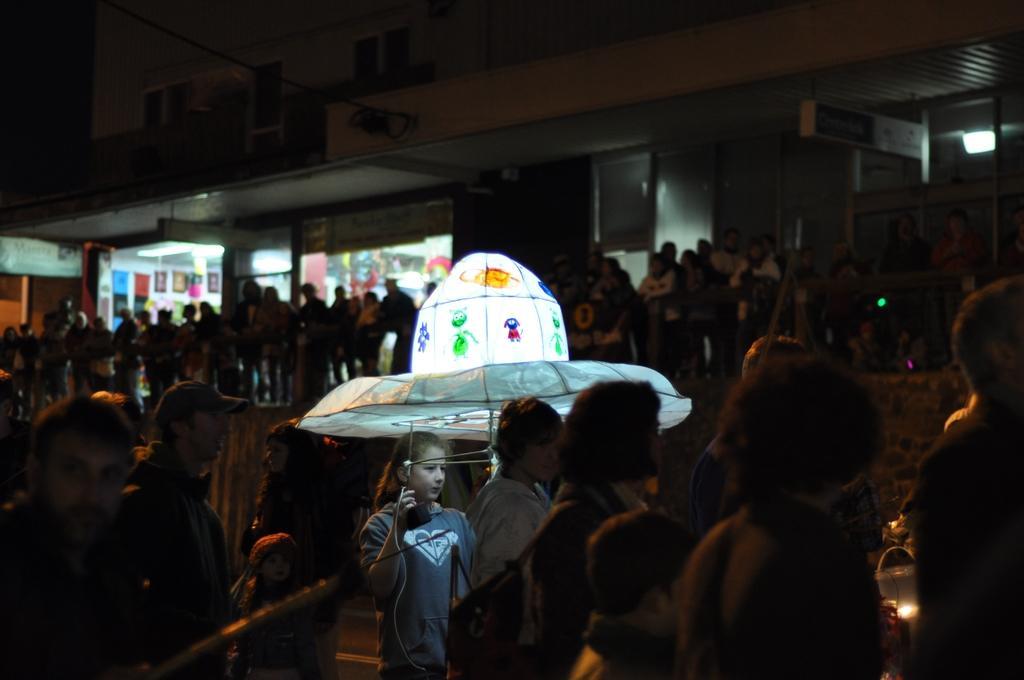Could you give a brief overview of what you see in this image? In this image we can see persons standing on the stairs, stores and a building. 